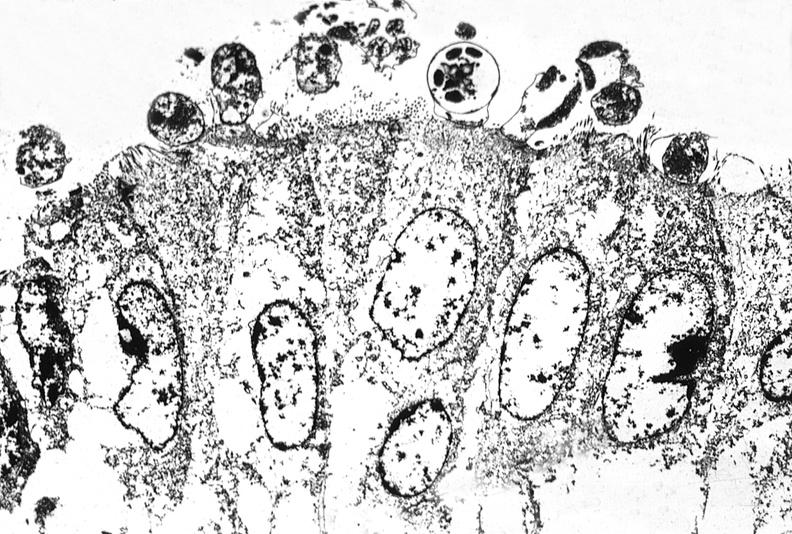what is present?
Answer the question using a single word or phrase. Gastrointestinal 